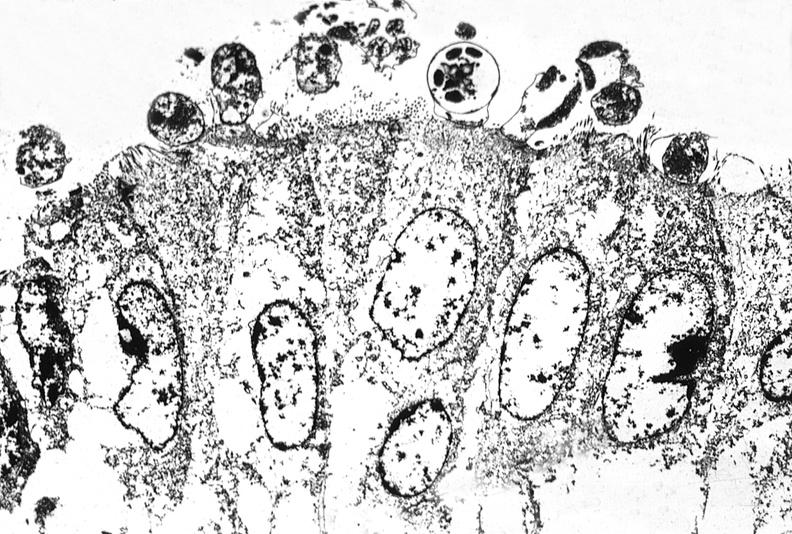what is present?
Answer the question using a single word or phrase. Gastrointestinal 